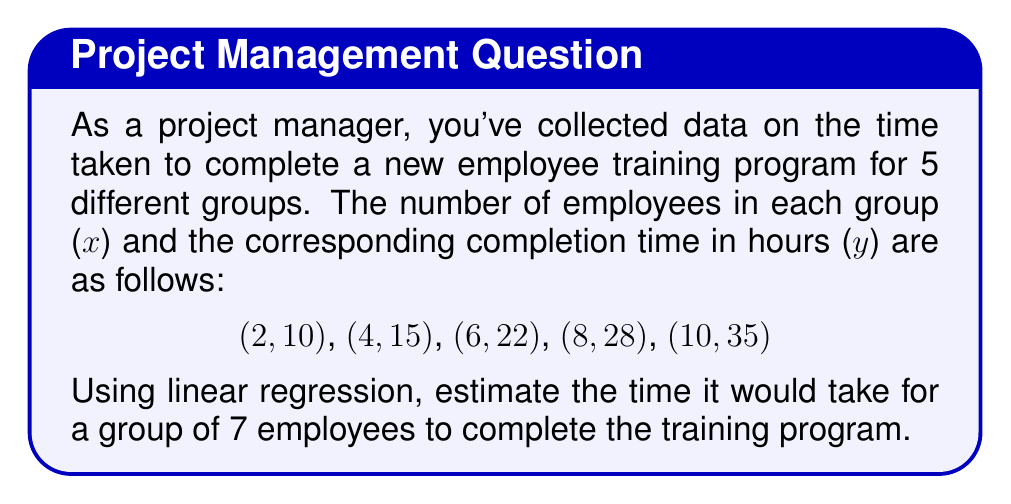Solve this math problem. To solve this problem using linear regression, we'll follow these steps:

1. Calculate the means of x and y:
   $$\bar{x} = \frac{2 + 4 + 6 + 8 + 10}{5} = 6$$
   $$\bar{y} = \frac{10 + 15 + 22 + 28 + 35}{5} = 22$$

2. Calculate the slope (m) using the formula:
   $$m = \frac{\sum(x_i - \bar{x})(y_i - \bar{y})}{\sum(x_i - \bar{x})^2}$$

   Let's calculate the numerator and denominator separately:
   
   Numerator: $(2-6)(10-22) + (4-6)(15-22) + (6-6)(22-22) + (8-6)(28-22) + (10-6)(35-22) = 140$
   
   Denominator: $(2-6)^2 + (4-6)^2 + (6-6)^2 + (8-6)^2 + (10-6)^2 = 60$

   $$m = \frac{140}{60} = \frac{7}{3} \approx 2.33$$

3. Calculate the y-intercept (b) using the formula:
   $$b = \bar{y} - m\bar{x}$$
   $$b = 22 - \frac{7}{3} \cdot 6 = 22 - 14 = 8$$

4. The linear regression equation is:
   $$y = mx + b = \frac{7}{3}x + 8$$

5. To estimate the time for a group of 7 employees, substitute x = 7:
   $$y = \frac{7}{3} \cdot 7 + 8 = \frac{49}{3} + 8 = \frac{73}{3} \approx 24.33$$

Therefore, the estimated time for a group of 7 employees to complete the training program is approximately 24.33 hours.
Answer: 24.33 hours 